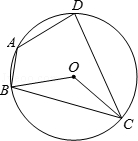Could this diagram have practical applications in real-world scenarios? Absolutely, such diagrams are not just theoretical but can be applied in various fields including engineering and architecture. For example, understanding the properties of inscribed angles and cyclic quadrilaterals can assist in designing rounded or arched structures, where stability and angle measurements play a crucial role. 